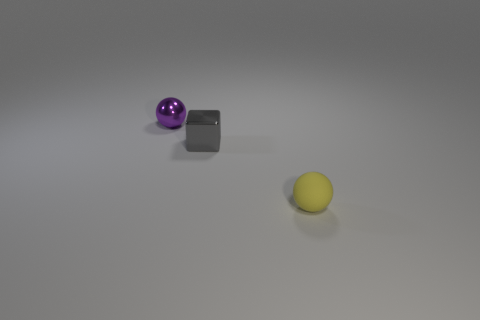Subtract 1 blocks. How many blocks are left? 0 Add 2 big purple metallic balls. How many objects exist? 5 Subtract all spheres. How many objects are left? 1 Subtract all purple blocks. How many purple spheres are left? 1 Subtract all purple shiny spheres. Subtract all small gray shiny blocks. How many objects are left? 1 Add 2 metal objects. How many metal objects are left? 4 Add 1 small purple shiny balls. How many small purple shiny balls exist? 2 Subtract all yellow spheres. How many spheres are left? 1 Subtract 1 gray cubes. How many objects are left? 2 Subtract all green spheres. Subtract all red cylinders. How many spheres are left? 2 